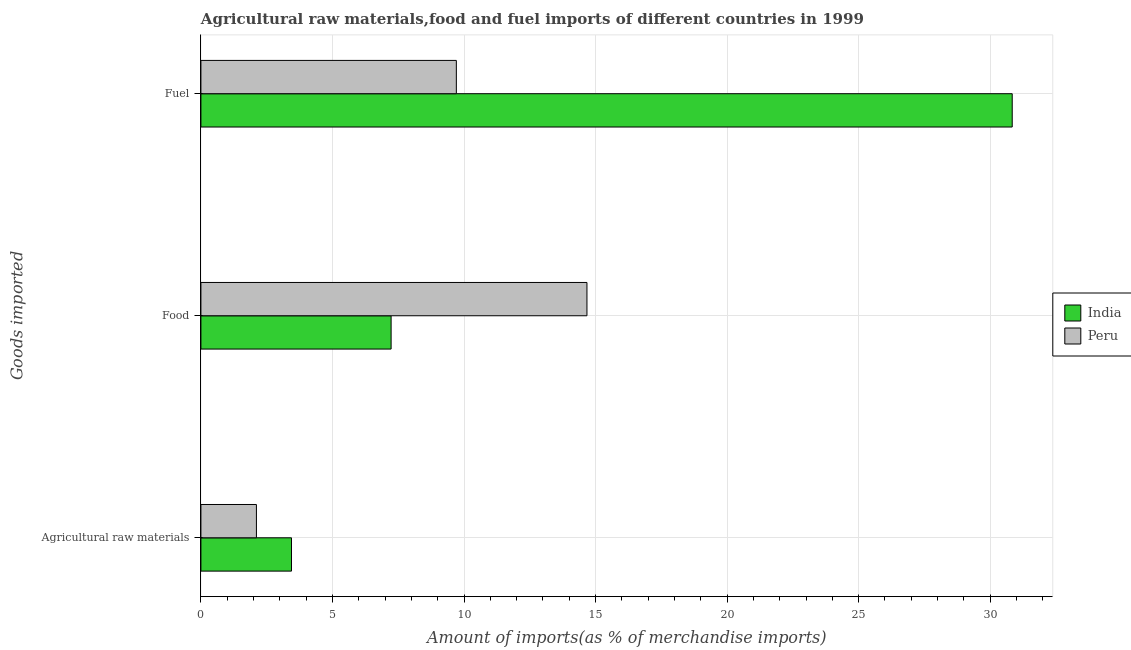How many groups of bars are there?
Your answer should be very brief. 3. What is the label of the 3rd group of bars from the top?
Keep it short and to the point. Agricultural raw materials. What is the percentage of fuel imports in Peru?
Offer a terse response. 9.71. Across all countries, what is the maximum percentage of food imports?
Provide a succinct answer. 14.67. Across all countries, what is the minimum percentage of food imports?
Your response must be concise. 7.23. In which country was the percentage of food imports minimum?
Give a very brief answer. India. What is the total percentage of food imports in the graph?
Your answer should be very brief. 21.9. What is the difference between the percentage of raw materials imports in Peru and that in India?
Provide a short and direct response. -1.33. What is the difference between the percentage of raw materials imports in India and the percentage of food imports in Peru?
Offer a terse response. -11.23. What is the average percentage of food imports per country?
Provide a succinct answer. 10.95. What is the difference between the percentage of food imports and percentage of raw materials imports in India?
Make the answer very short. 3.79. What is the ratio of the percentage of food imports in Peru to that in India?
Offer a terse response. 2.03. Is the percentage of fuel imports in India less than that in Peru?
Offer a terse response. No. Is the difference between the percentage of fuel imports in Peru and India greater than the difference between the percentage of food imports in Peru and India?
Your response must be concise. No. What is the difference between the highest and the second highest percentage of fuel imports?
Your answer should be very brief. 21.13. What is the difference between the highest and the lowest percentage of fuel imports?
Ensure brevity in your answer.  21.13. In how many countries, is the percentage of fuel imports greater than the average percentage of fuel imports taken over all countries?
Provide a short and direct response. 1. Is the sum of the percentage of raw materials imports in Peru and India greater than the maximum percentage of fuel imports across all countries?
Provide a short and direct response. No. Is it the case that in every country, the sum of the percentage of raw materials imports and percentage of food imports is greater than the percentage of fuel imports?
Provide a short and direct response. No. Are all the bars in the graph horizontal?
Provide a succinct answer. Yes. How many countries are there in the graph?
Ensure brevity in your answer.  2. Does the graph contain any zero values?
Keep it short and to the point. No. Does the graph contain grids?
Your answer should be very brief. Yes. What is the title of the graph?
Give a very brief answer. Agricultural raw materials,food and fuel imports of different countries in 1999. Does "Philippines" appear as one of the legend labels in the graph?
Make the answer very short. No. What is the label or title of the X-axis?
Your answer should be compact. Amount of imports(as % of merchandise imports). What is the label or title of the Y-axis?
Offer a terse response. Goods imported. What is the Amount of imports(as % of merchandise imports) of India in Agricultural raw materials?
Your answer should be compact. 3.44. What is the Amount of imports(as % of merchandise imports) in Peru in Agricultural raw materials?
Give a very brief answer. 2.11. What is the Amount of imports(as % of merchandise imports) in India in Food?
Your response must be concise. 7.23. What is the Amount of imports(as % of merchandise imports) in Peru in Food?
Provide a succinct answer. 14.67. What is the Amount of imports(as % of merchandise imports) in India in Fuel?
Provide a short and direct response. 30.84. What is the Amount of imports(as % of merchandise imports) of Peru in Fuel?
Give a very brief answer. 9.71. Across all Goods imported, what is the maximum Amount of imports(as % of merchandise imports) in India?
Offer a very short reply. 30.84. Across all Goods imported, what is the maximum Amount of imports(as % of merchandise imports) in Peru?
Provide a short and direct response. 14.67. Across all Goods imported, what is the minimum Amount of imports(as % of merchandise imports) in India?
Make the answer very short. 3.44. Across all Goods imported, what is the minimum Amount of imports(as % of merchandise imports) in Peru?
Your answer should be compact. 2.11. What is the total Amount of imports(as % of merchandise imports) of India in the graph?
Your answer should be compact. 41.51. What is the total Amount of imports(as % of merchandise imports) in Peru in the graph?
Ensure brevity in your answer.  26.49. What is the difference between the Amount of imports(as % of merchandise imports) of India in Agricultural raw materials and that in Food?
Offer a very short reply. -3.79. What is the difference between the Amount of imports(as % of merchandise imports) in Peru in Agricultural raw materials and that in Food?
Offer a terse response. -12.56. What is the difference between the Amount of imports(as % of merchandise imports) of India in Agricultural raw materials and that in Fuel?
Make the answer very short. -27.4. What is the difference between the Amount of imports(as % of merchandise imports) in Peru in Agricultural raw materials and that in Fuel?
Your answer should be very brief. -7.6. What is the difference between the Amount of imports(as % of merchandise imports) of India in Food and that in Fuel?
Keep it short and to the point. -23.61. What is the difference between the Amount of imports(as % of merchandise imports) of Peru in Food and that in Fuel?
Provide a succinct answer. 4.96. What is the difference between the Amount of imports(as % of merchandise imports) of India in Agricultural raw materials and the Amount of imports(as % of merchandise imports) of Peru in Food?
Give a very brief answer. -11.23. What is the difference between the Amount of imports(as % of merchandise imports) in India in Agricultural raw materials and the Amount of imports(as % of merchandise imports) in Peru in Fuel?
Offer a very short reply. -6.27. What is the difference between the Amount of imports(as % of merchandise imports) of India in Food and the Amount of imports(as % of merchandise imports) of Peru in Fuel?
Give a very brief answer. -2.48. What is the average Amount of imports(as % of merchandise imports) of India per Goods imported?
Your answer should be very brief. 13.84. What is the average Amount of imports(as % of merchandise imports) of Peru per Goods imported?
Your answer should be compact. 8.83. What is the difference between the Amount of imports(as % of merchandise imports) of India and Amount of imports(as % of merchandise imports) of Peru in Agricultural raw materials?
Your response must be concise. 1.33. What is the difference between the Amount of imports(as % of merchandise imports) of India and Amount of imports(as % of merchandise imports) of Peru in Food?
Keep it short and to the point. -7.44. What is the difference between the Amount of imports(as % of merchandise imports) of India and Amount of imports(as % of merchandise imports) of Peru in Fuel?
Give a very brief answer. 21.13. What is the ratio of the Amount of imports(as % of merchandise imports) of India in Agricultural raw materials to that in Food?
Provide a succinct answer. 0.48. What is the ratio of the Amount of imports(as % of merchandise imports) of Peru in Agricultural raw materials to that in Food?
Give a very brief answer. 0.14. What is the ratio of the Amount of imports(as % of merchandise imports) of India in Agricultural raw materials to that in Fuel?
Give a very brief answer. 0.11. What is the ratio of the Amount of imports(as % of merchandise imports) of Peru in Agricultural raw materials to that in Fuel?
Provide a succinct answer. 0.22. What is the ratio of the Amount of imports(as % of merchandise imports) of India in Food to that in Fuel?
Offer a terse response. 0.23. What is the ratio of the Amount of imports(as % of merchandise imports) of Peru in Food to that in Fuel?
Make the answer very short. 1.51. What is the difference between the highest and the second highest Amount of imports(as % of merchandise imports) in India?
Give a very brief answer. 23.61. What is the difference between the highest and the second highest Amount of imports(as % of merchandise imports) of Peru?
Offer a terse response. 4.96. What is the difference between the highest and the lowest Amount of imports(as % of merchandise imports) in India?
Your answer should be compact. 27.4. What is the difference between the highest and the lowest Amount of imports(as % of merchandise imports) in Peru?
Give a very brief answer. 12.56. 